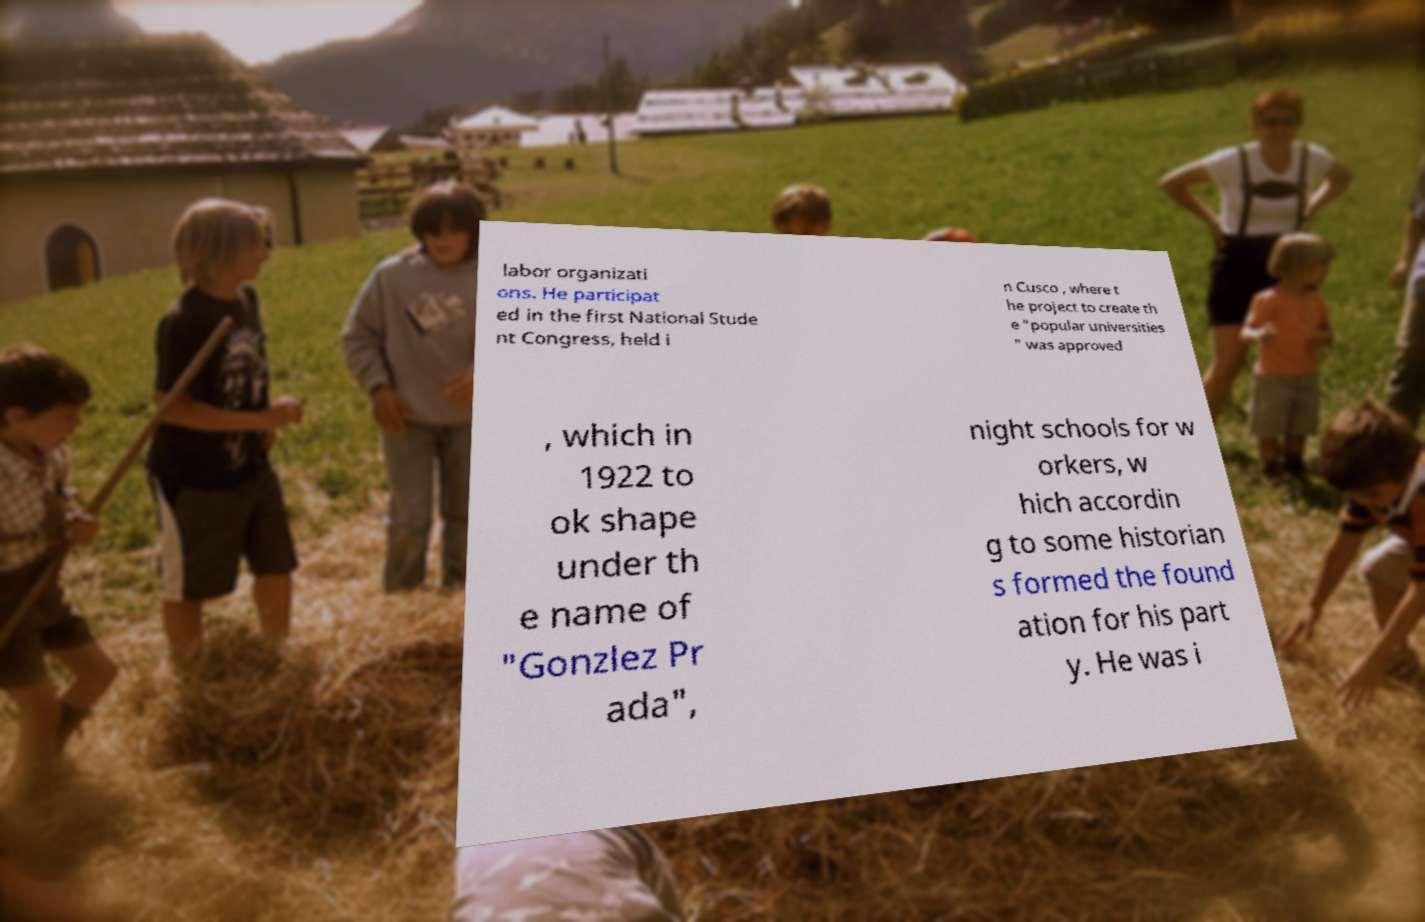Please identify and transcribe the text found in this image. labor organizati ons. He participat ed in the first National Stude nt Congress, held i n Cusco , where t he project to create th e "popular universities " was approved , which in 1922 to ok shape under th e name of "Gonzlez Pr ada", night schools for w orkers, w hich accordin g to some historian s formed the found ation for his part y. He was i 